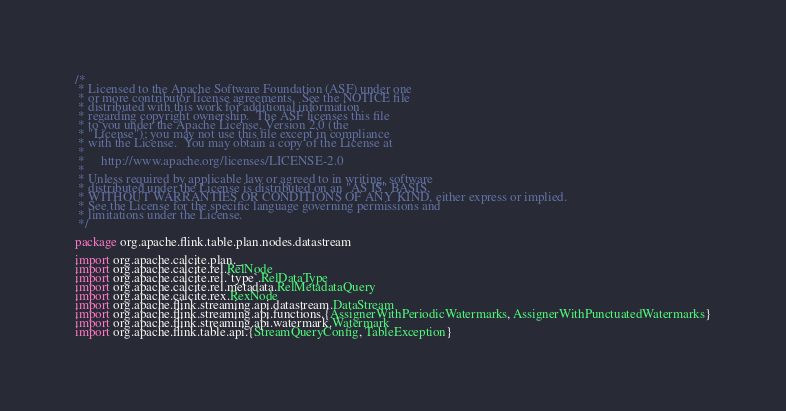<code> <loc_0><loc_0><loc_500><loc_500><_Scala_>/*
 * Licensed to the Apache Software Foundation (ASF) under one
 * or more contributor license agreements.  See the NOTICE file
 * distributed with this work for additional information
 * regarding copyright ownership.  The ASF licenses this file
 * to you under the Apache License, Version 2.0 (the
 * "License"); you may not use this file except in compliance
 * with the License.  You may obtain a copy of the License at
 *
 *     http://www.apache.org/licenses/LICENSE-2.0
 *
 * Unless required by applicable law or agreed to in writing, software
 * distributed under the License is distributed on an "AS IS" BASIS,
 * WITHOUT WARRANTIES OR CONDITIONS OF ANY KIND, either express or implied.
 * See the License for the specific language governing permissions and
 * limitations under the License.
 */

package org.apache.flink.table.plan.nodes.datastream

import org.apache.calcite.plan._
import org.apache.calcite.rel.RelNode
import org.apache.calcite.rel.`type`.RelDataType
import org.apache.calcite.rel.metadata.RelMetadataQuery
import org.apache.calcite.rex.RexNode
import org.apache.flink.streaming.api.datastream.DataStream
import org.apache.flink.streaming.api.functions.{AssignerWithPeriodicWatermarks, AssignerWithPunctuatedWatermarks}
import org.apache.flink.streaming.api.watermark.Watermark
import org.apache.flink.table.api.{StreamQueryConfig, TableException}</code> 